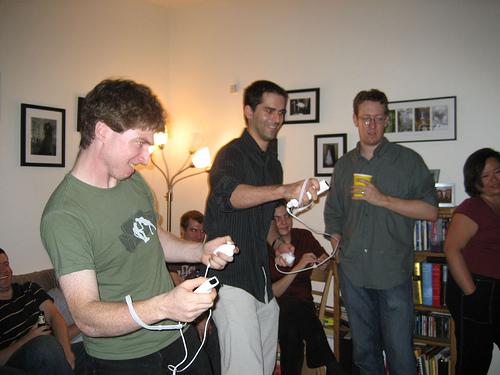Why are that man's arms up?
Be succinct. Playing wii. What are the two men in the front pretending to bite?
Write a very short answer. Nothing. How many men are wearing black shirts?
Answer briefly. 1. What game system are they playing?
Answer briefly. Wii. How many people are in the photo?
Be succinct. 7. What equipment are the men holding?
Concise answer only. Wii remotes. Can the lamp lights be adjusted?
Be succinct. Yes. Are the people enjoying themselves?
Concise answer only. Yes. Are these people at work?
Give a very brief answer. No. How many yellow shirts are in this picture?
Concise answer only. 0. What kind of glasses is he wearing?
Answer briefly. Eyeglasses. What is the man on the right holding in his hand?
Write a very short answer. Cup. How many in this photo are standing?
Answer briefly. 4. What is that on the arm?
Write a very short answer. Cord. 